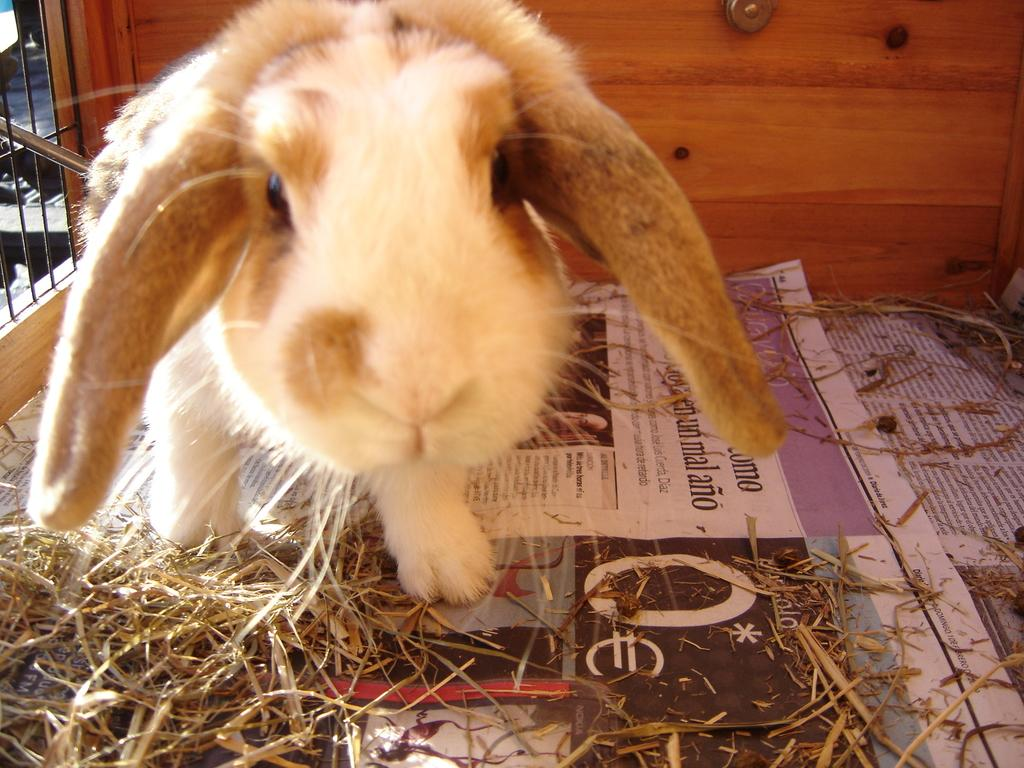What type of animal is in the image? There is a hamster in the image. What can be seen near the hamster? There are newspapers and dried grass in the image. What is the background of the image made of? There is a wooden wall in the background of the image. What else can be seen in the background of the image? There are objects visible in the background of the image. What is the title of the book the hamster is reading in the image? There is no book present in the image, and therefore no title can be determined. 